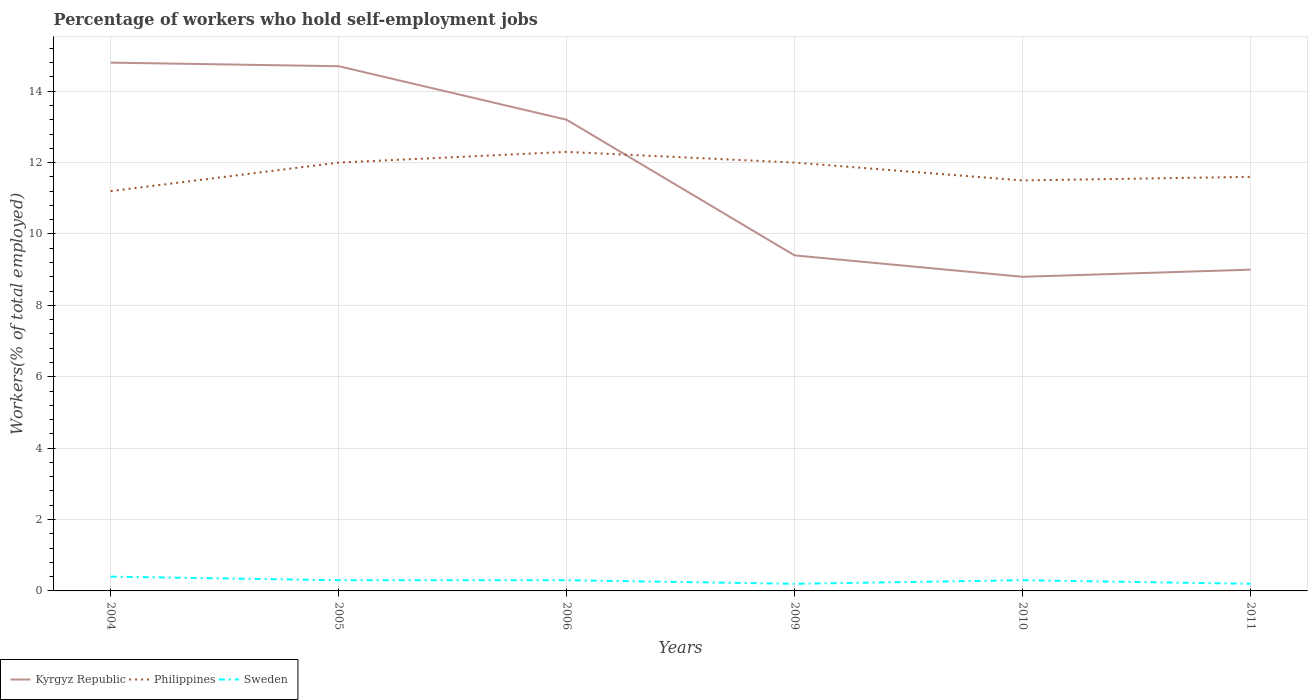Is the number of lines equal to the number of legend labels?
Your answer should be very brief. Yes. Across all years, what is the maximum percentage of self-employed workers in Kyrgyz Republic?
Give a very brief answer. 8.8. What is the total percentage of self-employed workers in Sweden in the graph?
Your response must be concise. 0.1. What is the difference between the highest and the second highest percentage of self-employed workers in Sweden?
Provide a succinct answer. 0.2. What is the difference between the highest and the lowest percentage of self-employed workers in Philippines?
Your response must be concise. 3. How many lines are there?
Keep it short and to the point. 3. What is the difference between two consecutive major ticks on the Y-axis?
Your answer should be very brief. 2. Are the values on the major ticks of Y-axis written in scientific E-notation?
Give a very brief answer. No. Does the graph contain any zero values?
Offer a terse response. No. What is the title of the graph?
Your answer should be very brief. Percentage of workers who hold self-employment jobs. What is the label or title of the X-axis?
Give a very brief answer. Years. What is the label or title of the Y-axis?
Provide a succinct answer. Workers(% of total employed). What is the Workers(% of total employed) in Kyrgyz Republic in 2004?
Provide a succinct answer. 14.8. What is the Workers(% of total employed) in Philippines in 2004?
Offer a terse response. 11.2. What is the Workers(% of total employed) in Sweden in 2004?
Your answer should be compact. 0.4. What is the Workers(% of total employed) of Kyrgyz Republic in 2005?
Provide a succinct answer. 14.7. What is the Workers(% of total employed) in Philippines in 2005?
Provide a succinct answer. 12. What is the Workers(% of total employed) of Sweden in 2005?
Make the answer very short. 0.3. What is the Workers(% of total employed) in Kyrgyz Republic in 2006?
Your answer should be very brief. 13.2. What is the Workers(% of total employed) of Philippines in 2006?
Keep it short and to the point. 12.3. What is the Workers(% of total employed) of Sweden in 2006?
Make the answer very short. 0.3. What is the Workers(% of total employed) in Kyrgyz Republic in 2009?
Provide a succinct answer. 9.4. What is the Workers(% of total employed) of Sweden in 2009?
Your answer should be very brief. 0.2. What is the Workers(% of total employed) in Kyrgyz Republic in 2010?
Provide a short and direct response. 8.8. What is the Workers(% of total employed) of Sweden in 2010?
Provide a succinct answer. 0.3. What is the Workers(% of total employed) in Philippines in 2011?
Offer a terse response. 11.6. What is the Workers(% of total employed) in Sweden in 2011?
Offer a very short reply. 0.2. Across all years, what is the maximum Workers(% of total employed) in Kyrgyz Republic?
Offer a very short reply. 14.8. Across all years, what is the maximum Workers(% of total employed) in Philippines?
Your answer should be compact. 12.3. Across all years, what is the maximum Workers(% of total employed) of Sweden?
Make the answer very short. 0.4. Across all years, what is the minimum Workers(% of total employed) in Kyrgyz Republic?
Your answer should be very brief. 8.8. Across all years, what is the minimum Workers(% of total employed) in Philippines?
Make the answer very short. 11.2. Across all years, what is the minimum Workers(% of total employed) in Sweden?
Your answer should be compact. 0.2. What is the total Workers(% of total employed) in Kyrgyz Republic in the graph?
Make the answer very short. 69.9. What is the total Workers(% of total employed) in Philippines in the graph?
Ensure brevity in your answer.  70.6. What is the difference between the Workers(% of total employed) of Kyrgyz Republic in 2004 and that in 2006?
Keep it short and to the point. 1.6. What is the difference between the Workers(% of total employed) in Philippines in 2004 and that in 2006?
Make the answer very short. -1.1. What is the difference between the Workers(% of total employed) of Sweden in 2004 and that in 2009?
Your answer should be compact. 0.2. What is the difference between the Workers(% of total employed) of Kyrgyz Republic in 2004 and that in 2010?
Ensure brevity in your answer.  6. What is the difference between the Workers(% of total employed) of Sweden in 2004 and that in 2010?
Provide a short and direct response. 0.1. What is the difference between the Workers(% of total employed) in Kyrgyz Republic in 2004 and that in 2011?
Keep it short and to the point. 5.8. What is the difference between the Workers(% of total employed) in Philippines in 2004 and that in 2011?
Ensure brevity in your answer.  -0.4. What is the difference between the Workers(% of total employed) of Sweden in 2004 and that in 2011?
Your response must be concise. 0.2. What is the difference between the Workers(% of total employed) in Philippines in 2005 and that in 2006?
Give a very brief answer. -0.3. What is the difference between the Workers(% of total employed) of Philippines in 2005 and that in 2009?
Ensure brevity in your answer.  0. What is the difference between the Workers(% of total employed) in Sweden in 2005 and that in 2009?
Offer a terse response. 0.1. What is the difference between the Workers(% of total employed) in Kyrgyz Republic in 2005 and that in 2010?
Your answer should be very brief. 5.9. What is the difference between the Workers(% of total employed) in Sweden in 2005 and that in 2010?
Offer a terse response. 0. What is the difference between the Workers(% of total employed) of Kyrgyz Republic in 2005 and that in 2011?
Your response must be concise. 5.7. What is the difference between the Workers(% of total employed) of Sweden in 2005 and that in 2011?
Ensure brevity in your answer.  0.1. What is the difference between the Workers(% of total employed) in Kyrgyz Republic in 2006 and that in 2009?
Keep it short and to the point. 3.8. What is the difference between the Workers(% of total employed) in Philippines in 2006 and that in 2009?
Offer a very short reply. 0.3. What is the difference between the Workers(% of total employed) of Kyrgyz Republic in 2006 and that in 2010?
Offer a very short reply. 4.4. What is the difference between the Workers(% of total employed) of Kyrgyz Republic in 2006 and that in 2011?
Give a very brief answer. 4.2. What is the difference between the Workers(% of total employed) of Kyrgyz Republic in 2009 and that in 2010?
Ensure brevity in your answer.  0.6. What is the difference between the Workers(% of total employed) of Philippines in 2009 and that in 2010?
Offer a very short reply. 0.5. What is the difference between the Workers(% of total employed) in Kyrgyz Republic in 2010 and that in 2011?
Offer a terse response. -0.2. What is the difference between the Workers(% of total employed) in Kyrgyz Republic in 2004 and the Workers(% of total employed) in Philippines in 2006?
Keep it short and to the point. 2.5. What is the difference between the Workers(% of total employed) of Kyrgyz Republic in 2004 and the Workers(% of total employed) of Sweden in 2006?
Your answer should be very brief. 14.5. What is the difference between the Workers(% of total employed) of Philippines in 2004 and the Workers(% of total employed) of Sweden in 2006?
Ensure brevity in your answer.  10.9. What is the difference between the Workers(% of total employed) in Kyrgyz Republic in 2004 and the Workers(% of total employed) in Philippines in 2009?
Provide a succinct answer. 2.8. What is the difference between the Workers(% of total employed) of Kyrgyz Republic in 2004 and the Workers(% of total employed) of Sweden in 2009?
Keep it short and to the point. 14.6. What is the difference between the Workers(% of total employed) in Kyrgyz Republic in 2004 and the Workers(% of total employed) in Sweden in 2010?
Offer a terse response. 14.5. What is the difference between the Workers(% of total employed) in Philippines in 2004 and the Workers(% of total employed) in Sweden in 2010?
Provide a succinct answer. 10.9. What is the difference between the Workers(% of total employed) in Kyrgyz Republic in 2004 and the Workers(% of total employed) in Sweden in 2011?
Your response must be concise. 14.6. What is the difference between the Workers(% of total employed) in Philippines in 2005 and the Workers(% of total employed) in Sweden in 2006?
Make the answer very short. 11.7. What is the difference between the Workers(% of total employed) of Kyrgyz Republic in 2005 and the Workers(% of total employed) of Sweden in 2009?
Your answer should be compact. 14.5. What is the difference between the Workers(% of total employed) of Philippines in 2005 and the Workers(% of total employed) of Sweden in 2009?
Give a very brief answer. 11.8. What is the difference between the Workers(% of total employed) in Kyrgyz Republic in 2005 and the Workers(% of total employed) in Philippines in 2010?
Provide a short and direct response. 3.2. What is the difference between the Workers(% of total employed) of Kyrgyz Republic in 2005 and the Workers(% of total employed) of Sweden in 2010?
Ensure brevity in your answer.  14.4. What is the difference between the Workers(% of total employed) of Philippines in 2005 and the Workers(% of total employed) of Sweden in 2010?
Ensure brevity in your answer.  11.7. What is the difference between the Workers(% of total employed) in Kyrgyz Republic in 2005 and the Workers(% of total employed) in Philippines in 2011?
Offer a very short reply. 3.1. What is the difference between the Workers(% of total employed) in Kyrgyz Republic in 2005 and the Workers(% of total employed) in Sweden in 2011?
Give a very brief answer. 14.5. What is the difference between the Workers(% of total employed) of Kyrgyz Republic in 2006 and the Workers(% of total employed) of Philippines in 2009?
Offer a very short reply. 1.2. What is the difference between the Workers(% of total employed) of Kyrgyz Republic in 2006 and the Workers(% of total employed) of Sweden in 2009?
Give a very brief answer. 13. What is the difference between the Workers(% of total employed) of Kyrgyz Republic in 2006 and the Workers(% of total employed) of Sweden in 2010?
Offer a very short reply. 12.9. What is the difference between the Workers(% of total employed) of Philippines in 2006 and the Workers(% of total employed) of Sweden in 2010?
Keep it short and to the point. 12. What is the difference between the Workers(% of total employed) in Kyrgyz Republic in 2006 and the Workers(% of total employed) in Philippines in 2011?
Give a very brief answer. 1.6. What is the difference between the Workers(% of total employed) in Philippines in 2009 and the Workers(% of total employed) in Sweden in 2010?
Ensure brevity in your answer.  11.7. What is the difference between the Workers(% of total employed) in Kyrgyz Republic in 2009 and the Workers(% of total employed) in Philippines in 2011?
Ensure brevity in your answer.  -2.2. What is the difference between the Workers(% of total employed) in Kyrgyz Republic in 2009 and the Workers(% of total employed) in Sweden in 2011?
Offer a very short reply. 9.2. What is the difference between the Workers(% of total employed) in Kyrgyz Republic in 2010 and the Workers(% of total employed) in Philippines in 2011?
Offer a very short reply. -2.8. What is the average Workers(% of total employed) of Kyrgyz Republic per year?
Make the answer very short. 11.65. What is the average Workers(% of total employed) of Philippines per year?
Provide a succinct answer. 11.77. What is the average Workers(% of total employed) in Sweden per year?
Give a very brief answer. 0.28. In the year 2004, what is the difference between the Workers(% of total employed) in Kyrgyz Republic and Workers(% of total employed) in Philippines?
Offer a very short reply. 3.6. In the year 2004, what is the difference between the Workers(% of total employed) in Philippines and Workers(% of total employed) in Sweden?
Offer a very short reply. 10.8. In the year 2005, what is the difference between the Workers(% of total employed) of Philippines and Workers(% of total employed) of Sweden?
Make the answer very short. 11.7. In the year 2006, what is the difference between the Workers(% of total employed) in Kyrgyz Republic and Workers(% of total employed) in Sweden?
Keep it short and to the point. 12.9. In the year 2009, what is the difference between the Workers(% of total employed) in Philippines and Workers(% of total employed) in Sweden?
Make the answer very short. 11.8. In the year 2010, what is the difference between the Workers(% of total employed) in Kyrgyz Republic and Workers(% of total employed) in Sweden?
Offer a terse response. 8.5. What is the ratio of the Workers(% of total employed) in Kyrgyz Republic in 2004 to that in 2005?
Keep it short and to the point. 1.01. What is the ratio of the Workers(% of total employed) in Philippines in 2004 to that in 2005?
Keep it short and to the point. 0.93. What is the ratio of the Workers(% of total employed) of Kyrgyz Republic in 2004 to that in 2006?
Provide a succinct answer. 1.12. What is the ratio of the Workers(% of total employed) of Philippines in 2004 to that in 2006?
Give a very brief answer. 0.91. What is the ratio of the Workers(% of total employed) in Kyrgyz Republic in 2004 to that in 2009?
Provide a short and direct response. 1.57. What is the ratio of the Workers(% of total employed) in Philippines in 2004 to that in 2009?
Your answer should be compact. 0.93. What is the ratio of the Workers(% of total employed) of Sweden in 2004 to that in 2009?
Ensure brevity in your answer.  2. What is the ratio of the Workers(% of total employed) in Kyrgyz Republic in 2004 to that in 2010?
Your answer should be very brief. 1.68. What is the ratio of the Workers(% of total employed) in Philippines in 2004 to that in 2010?
Ensure brevity in your answer.  0.97. What is the ratio of the Workers(% of total employed) of Kyrgyz Republic in 2004 to that in 2011?
Offer a very short reply. 1.64. What is the ratio of the Workers(% of total employed) of Philippines in 2004 to that in 2011?
Offer a terse response. 0.97. What is the ratio of the Workers(% of total employed) of Sweden in 2004 to that in 2011?
Give a very brief answer. 2. What is the ratio of the Workers(% of total employed) in Kyrgyz Republic in 2005 to that in 2006?
Your answer should be very brief. 1.11. What is the ratio of the Workers(% of total employed) in Philippines in 2005 to that in 2006?
Your answer should be very brief. 0.98. What is the ratio of the Workers(% of total employed) of Sweden in 2005 to that in 2006?
Your response must be concise. 1. What is the ratio of the Workers(% of total employed) of Kyrgyz Republic in 2005 to that in 2009?
Your answer should be compact. 1.56. What is the ratio of the Workers(% of total employed) of Sweden in 2005 to that in 2009?
Offer a very short reply. 1.5. What is the ratio of the Workers(% of total employed) in Kyrgyz Republic in 2005 to that in 2010?
Your answer should be very brief. 1.67. What is the ratio of the Workers(% of total employed) of Philippines in 2005 to that in 2010?
Your response must be concise. 1.04. What is the ratio of the Workers(% of total employed) of Kyrgyz Republic in 2005 to that in 2011?
Provide a short and direct response. 1.63. What is the ratio of the Workers(% of total employed) of Philippines in 2005 to that in 2011?
Your answer should be very brief. 1.03. What is the ratio of the Workers(% of total employed) in Sweden in 2005 to that in 2011?
Your response must be concise. 1.5. What is the ratio of the Workers(% of total employed) in Kyrgyz Republic in 2006 to that in 2009?
Provide a succinct answer. 1.4. What is the ratio of the Workers(% of total employed) in Philippines in 2006 to that in 2009?
Keep it short and to the point. 1.02. What is the ratio of the Workers(% of total employed) of Kyrgyz Republic in 2006 to that in 2010?
Keep it short and to the point. 1.5. What is the ratio of the Workers(% of total employed) of Philippines in 2006 to that in 2010?
Offer a very short reply. 1.07. What is the ratio of the Workers(% of total employed) of Sweden in 2006 to that in 2010?
Ensure brevity in your answer.  1. What is the ratio of the Workers(% of total employed) in Kyrgyz Republic in 2006 to that in 2011?
Keep it short and to the point. 1.47. What is the ratio of the Workers(% of total employed) in Philippines in 2006 to that in 2011?
Keep it short and to the point. 1.06. What is the ratio of the Workers(% of total employed) in Sweden in 2006 to that in 2011?
Keep it short and to the point. 1.5. What is the ratio of the Workers(% of total employed) of Kyrgyz Republic in 2009 to that in 2010?
Provide a succinct answer. 1.07. What is the ratio of the Workers(% of total employed) in Philippines in 2009 to that in 2010?
Provide a short and direct response. 1.04. What is the ratio of the Workers(% of total employed) in Kyrgyz Republic in 2009 to that in 2011?
Offer a very short reply. 1.04. What is the ratio of the Workers(% of total employed) in Philippines in 2009 to that in 2011?
Provide a short and direct response. 1.03. What is the ratio of the Workers(% of total employed) of Kyrgyz Republic in 2010 to that in 2011?
Keep it short and to the point. 0.98. What is the ratio of the Workers(% of total employed) of Sweden in 2010 to that in 2011?
Provide a succinct answer. 1.5. What is the difference between the highest and the second highest Workers(% of total employed) in Kyrgyz Republic?
Your answer should be compact. 0.1. What is the difference between the highest and the lowest Workers(% of total employed) of Kyrgyz Republic?
Your answer should be very brief. 6. 